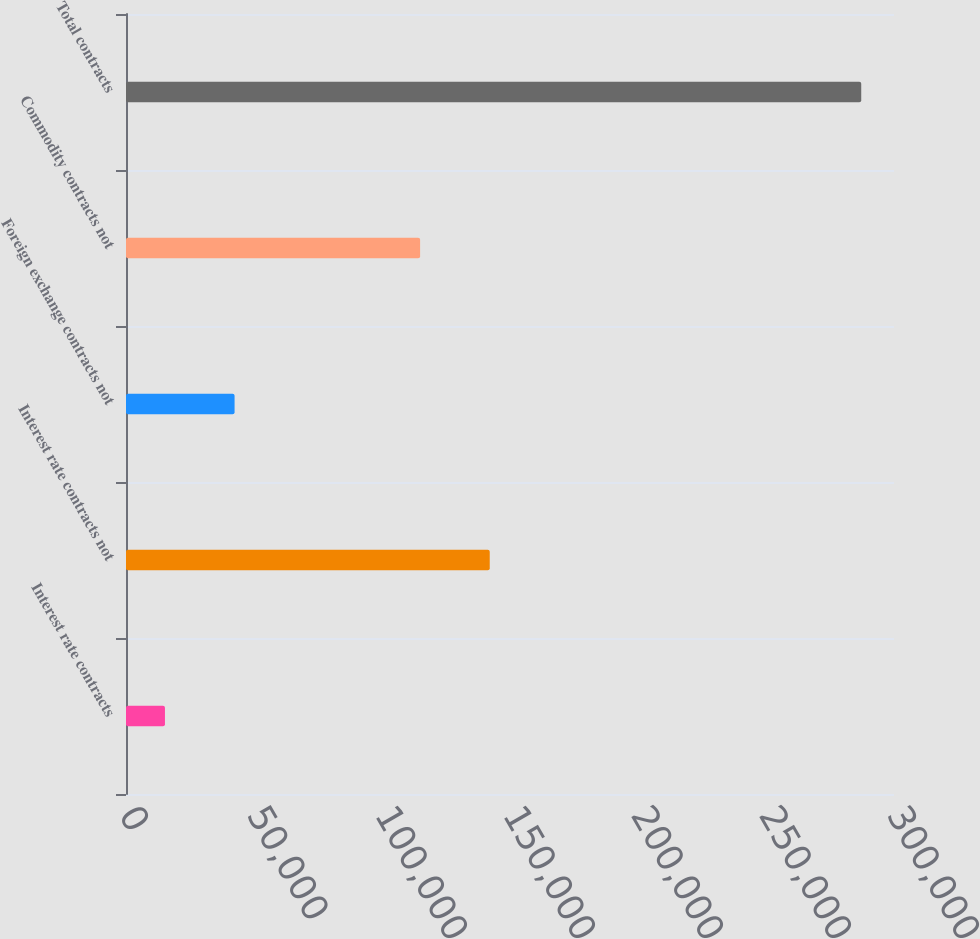Convert chart. <chart><loc_0><loc_0><loc_500><loc_500><bar_chart><fcel>Interest rate contracts<fcel>Interest rate contracts not<fcel>Foreign exchange contracts not<fcel>Commodity contracts not<fcel>Total contracts<nl><fcel>15215<fcel>142086<fcel>42413.5<fcel>114887<fcel>287200<nl></chart> 